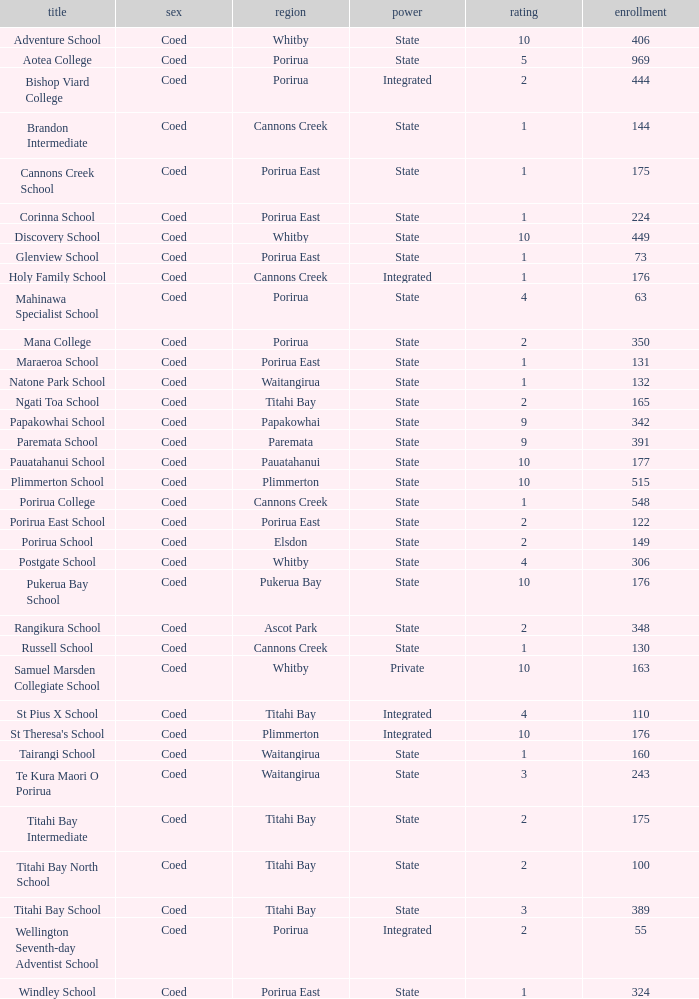What integrated school had a decile of 2 and a roll larger than 55? Bishop Viard College. 